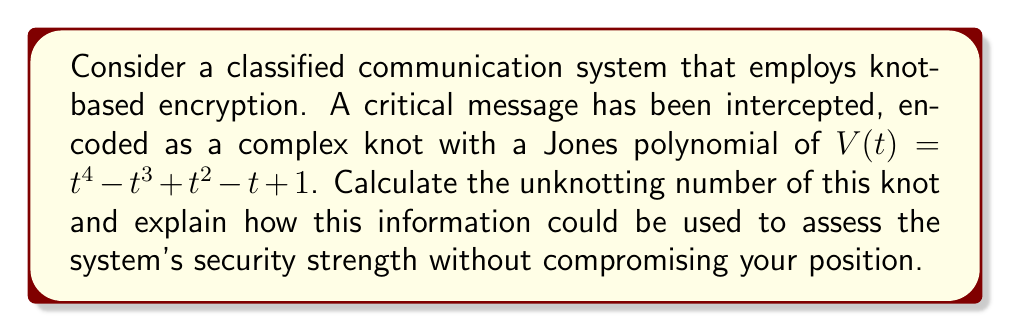Provide a solution to this math problem. To solve this problem, we'll follow these steps:

1) The Jones polynomial $V(t) = t^4 - t^3 + t^2 - t + 1$ corresponds to the figure-eight knot, also known as the $4_1$ knot in the Alexander-Briggs notation.

2) The unknotting number of a knot is the minimum number of crossing changes required to transform the knot into the unknot (trivial knot).

3) For the figure-eight knot, it's known that the unknotting number is 1. This can be verified by changing any one of its crossings, which results in the unknot.

4) To assess the security strength without compromising your position:

   a) The unknotting number provides a lower bound on the computational complexity of decrypting the message.
   
   b) An unknotting number of 1 suggests that the encryption might be vulnerable to single-point failures or simple attacks.
   
   c) However, finding the correct crossing to change among all possibilities can still be computationally challenging for complex knots.
   
   d) The security of the system also depends on other factors, such as the method of converting the message to a knot and the overall encryption protocol.

5) As a high-ranking official, you can use this information to:

   a) Privately advise on potential vulnerabilities without publicly endorsing or criticizing the system.
   
   b) Recommend internal security audits or research into more complex knot-based encryption methods.
   
   c) Suggest exploring additional layers of security to complement the knot-based system.

This analysis provides valuable insight into the system's security without explicitly revealing any classified information or publicly taking a stance on the encryption method.
Answer: 1 